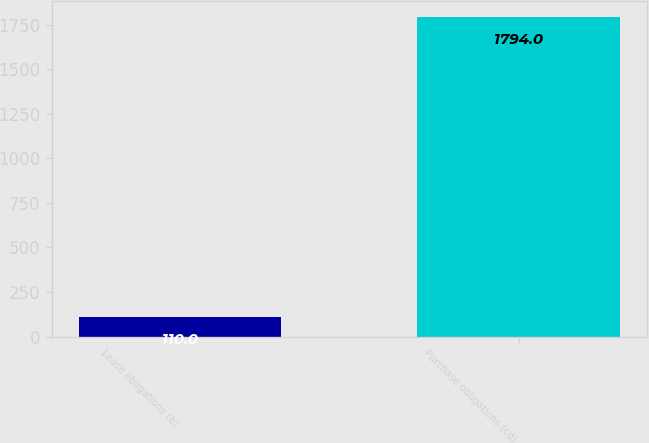Convert chart to OTSL. <chart><loc_0><loc_0><loc_500><loc_500><bar_chart><fcel>Lease obligations (b)<fcel>Purchase obligations (cd)<nl><fcel>110<fcel>1794<nl></chart> 